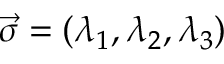<formula> <loc_0><loc_0><loc_500><loc_500>\vec { \sigma } = ( \lambda _ { 1 } , \lambda _ { 2 } , \lambda _ { 3 } )</formula> 